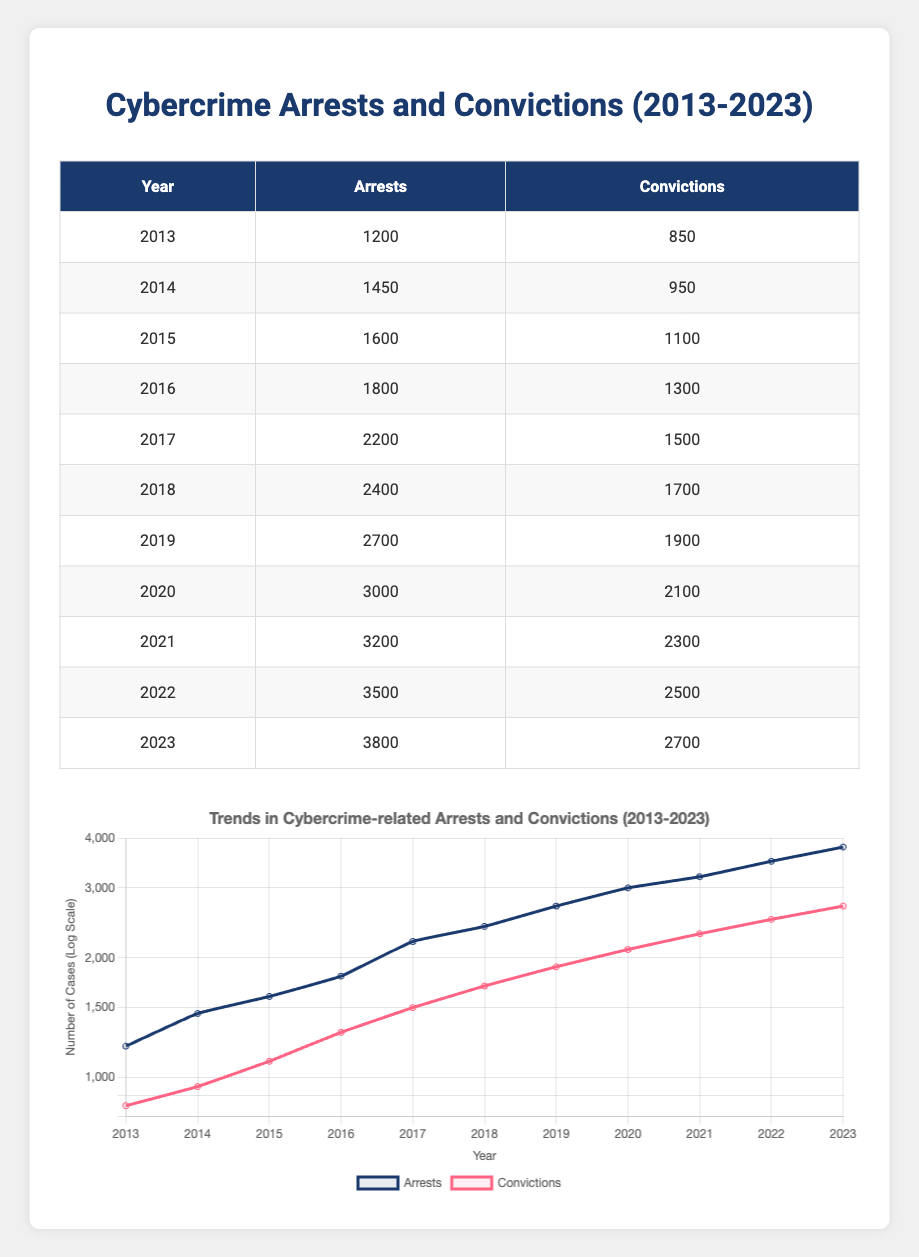What was the total number of arrests in 2016? In the row for 2016, the number of arrests is directly listed as 1800.
Answer: 1800 How many more convictions were there in 2023 compared to 2013? The number of convictions in 2023 is 2700, and in 2013 it is 850. Subtracting these values gives 2700 - 850 = 1850.
Answer: 1850 What year had the highest number of arrests? Looking through the arrests column, the highest number is 3800, which is in the year 2023.
Answer: 2023 Did the number of arrests ever decrease from one year to the next? By reviewing the arrests data year by year, it is observed that the number of arrests increases every year from 2013 to 2023. Therefore, there were no decreases.
Answer: No What is the average number of convictions from 2013 to 2023? To calculate the average, add up all the convictions from each year: (850 + 950 + 1100 + 1300 + 1500 + 1700 + 1900 + 2100 + 2300 + 2500 + 2700) = 18100. There are 11 years, so dividing gives 18100 / 11 = approximately 1645.45.
Answer: 1645.45 How many total arrests were made in the years 2017 and 2018 combined? The number of arrests in 2017 is 2200 and in 2018 is 2400. Adding these gives 2200 + 2400 = 4600.
Answer: 4600 Was the number of convictions in 2021 greater than the number of arrests in 2018? The number of convictions in 2021 is 2300, and the number of arrests in 2018 is 2400. Since 2300 is not greater than 2400, the answer is no.
Answer: No What was the percentage increase in arrests from 2013 to 2022? The number of arrests in 2013 is 1200 and in 2022 is 3500. The increase is 3500 - 1200 = 2300. The percentage increase is (2300 / 1200) * 100 = approximately 191.67%.
Answer: 191.67% Which year saw the lowest ratio of convictions to arrests? To find the ratio, divide the number of convictions by the number of arrests for each year. The year with the lowest ratio is 2013, where the ratio is 850/1200 = 0.708. Comparing all ratios, this year has the lowest.
Answer: 2013 